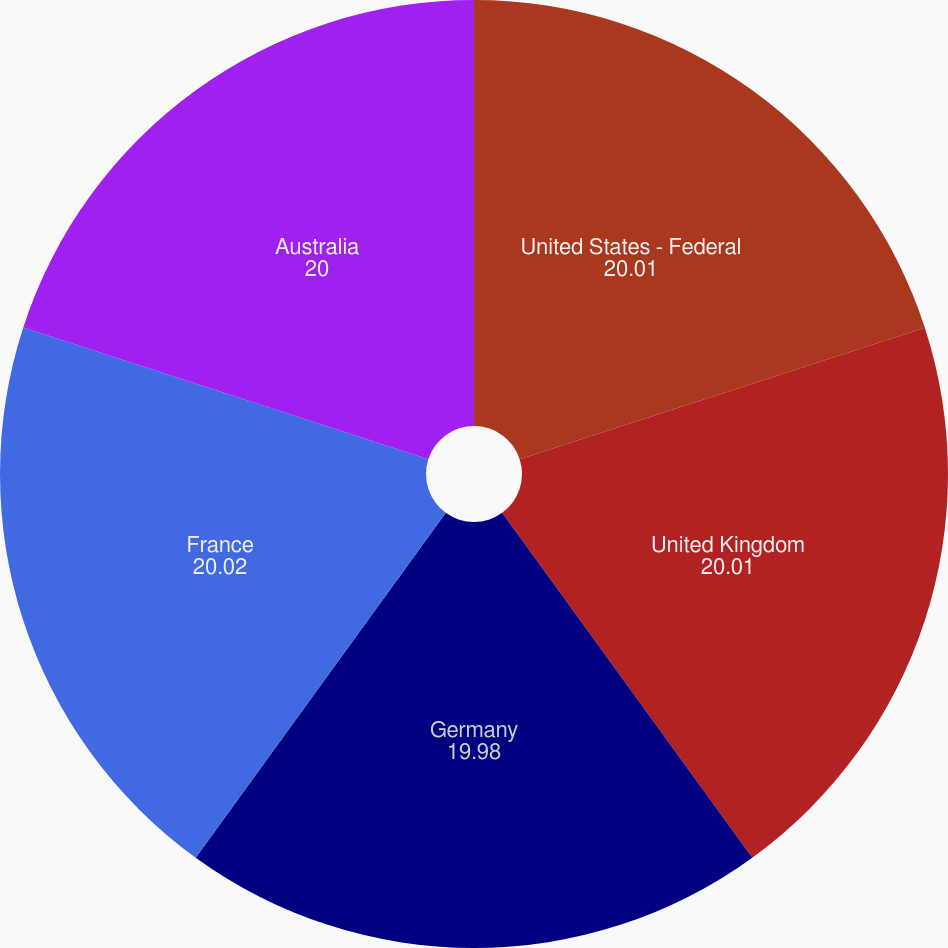Convert chart to OTSL. <chart><loc_0><loc_0><loc_500><loc_500><pie_chart><fcel>United States - Federal<fcel>United Kingdom<fcel>Germany<fcel>France<fcel>Australia<nl><fcel>20.01%<fcel>20.01%<fcel>19.98%<fcel>20.02%<fcel>20.0%<nl></chart> 